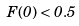Convert formula to latex. <formula><loc_0><loc_0><loc_500><loc_500>F ( 0 ) < 0 . 5</formula> 